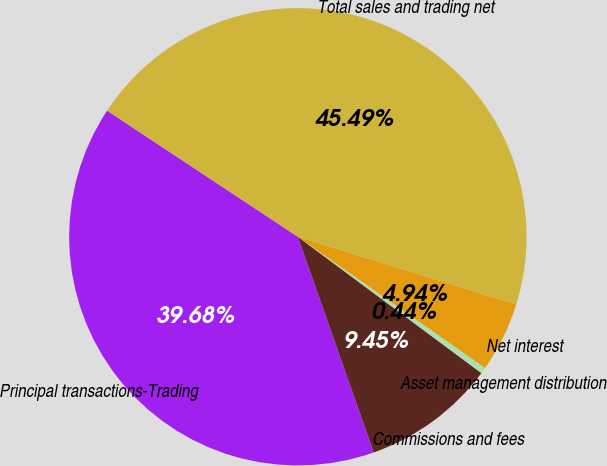Convert chart to OTSL. <chart><loc_0><loc_0><loc_500><loc_500><pie_chart><fcel>Principal transactions-Trading<fcel>Commissions and fees<fcel>Asset management distribution<fcel>Net interest<fcel>Total sales and trading net<nl><fcel>39.68%<fcel>9.45%<fcel>0.44%<fcel>4.94%<fcel>45.49%<nl></chart> 